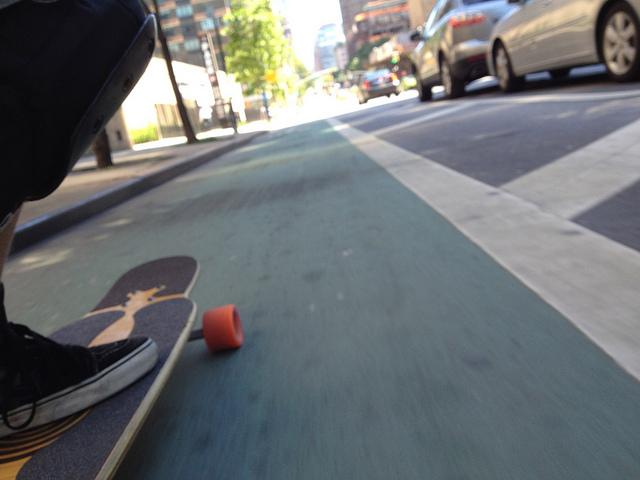What is on top of the skateboard?

Choices:
A) elephant
B) cat
C) sneaker
D) dog paw sneaker 